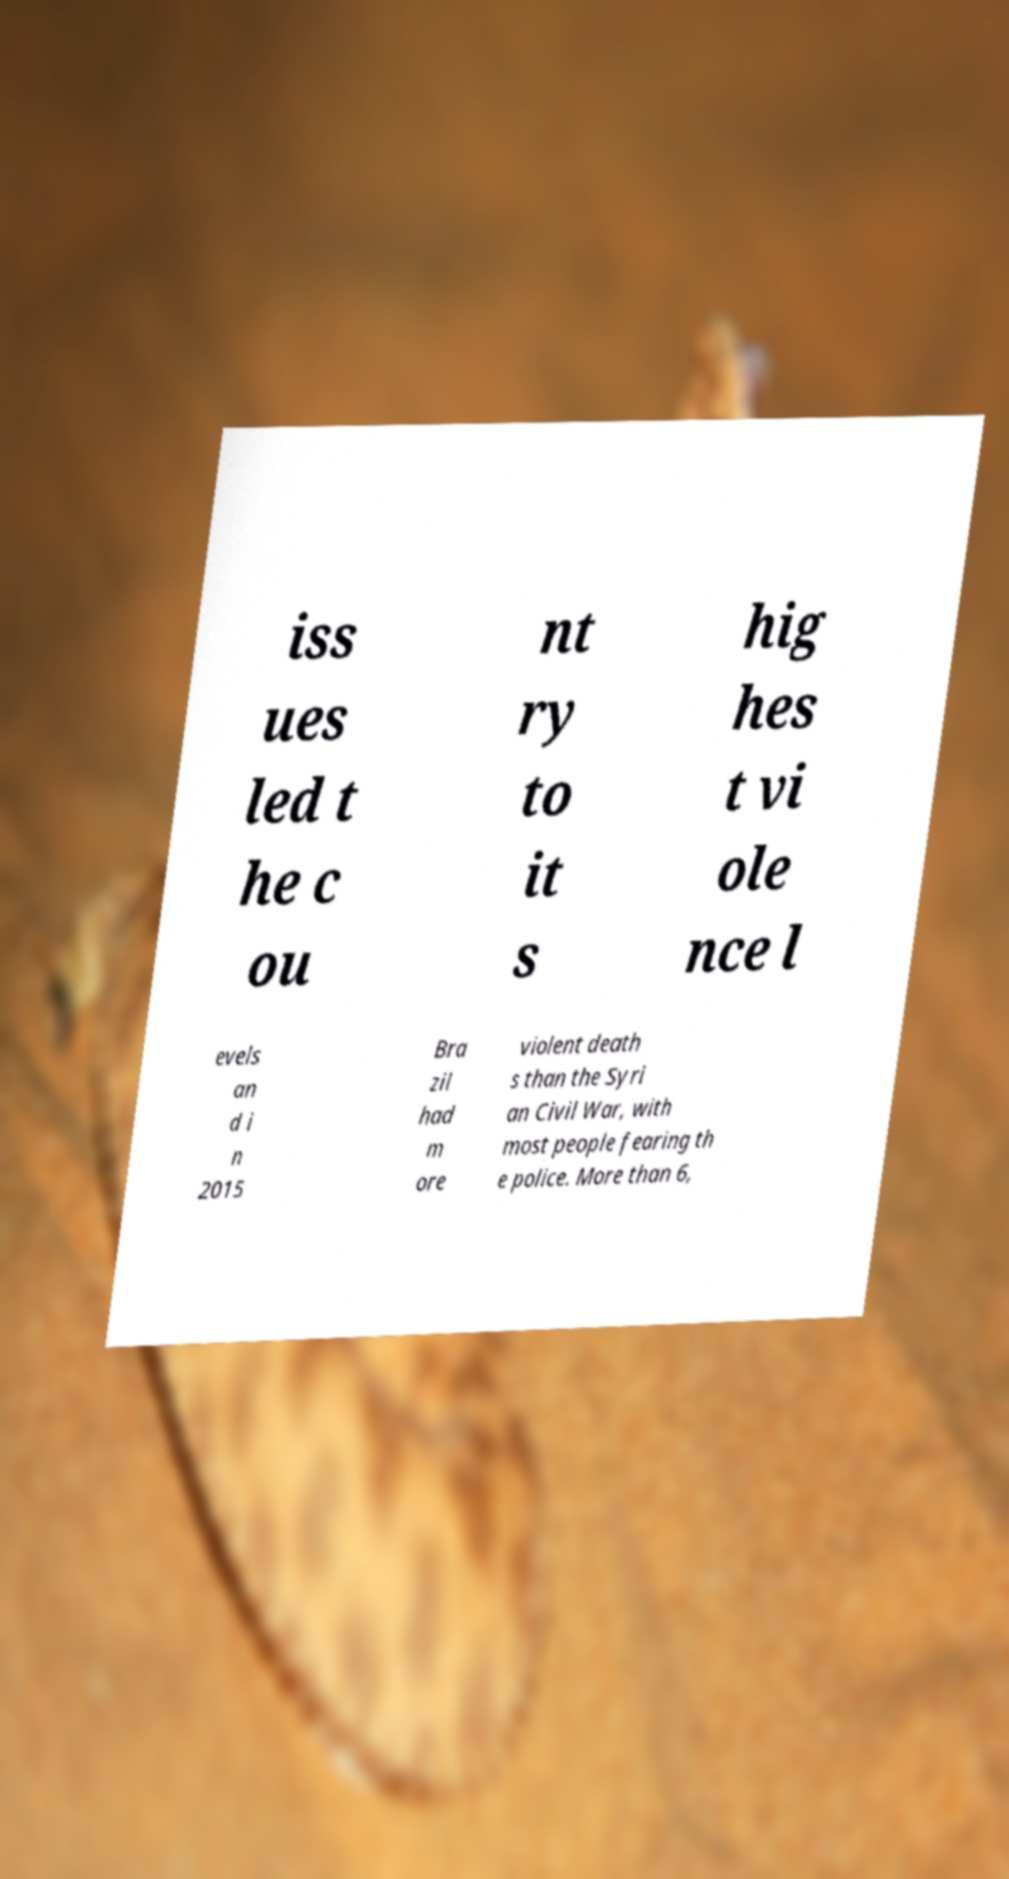Can you read and provide the text displayed in the image?This photo seems to have some interesting text. Can you extract and type it out for me? iss ues led t he c ou nt ry to it s hig hes t vi ole nce l evels an d i n 2015 Bra zil had m ore violent death s than the Syri an Civil War, with most people fearing th e police. More than 6, 